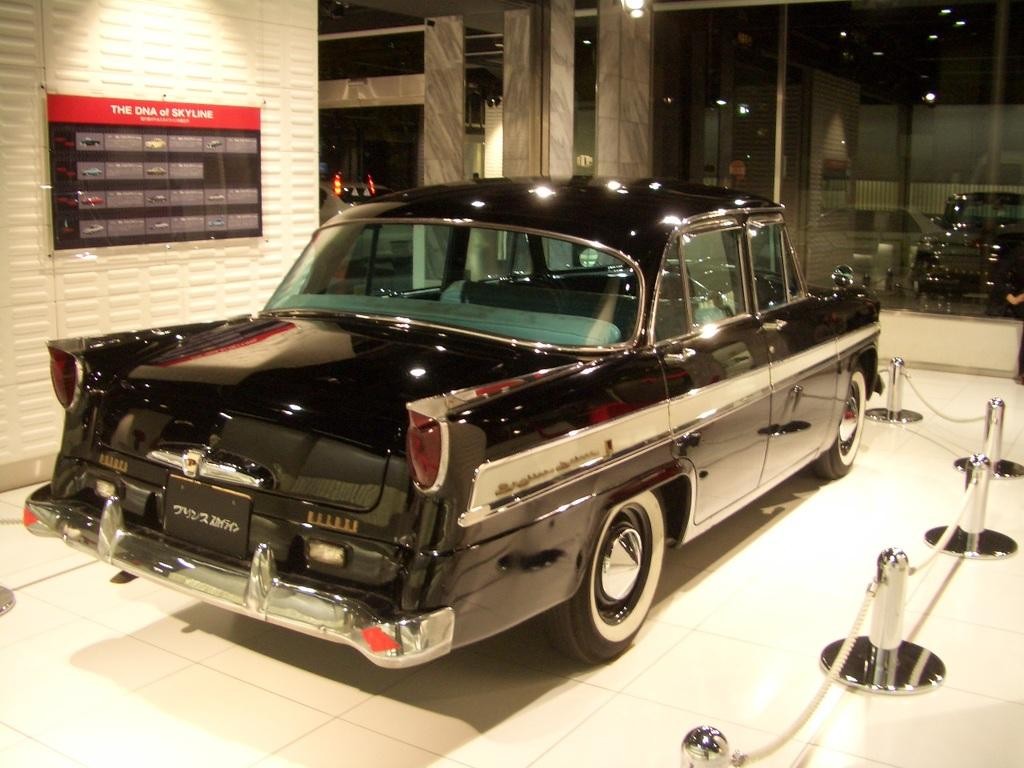What is the main subject of the image? There is a car in the image. Can you describe the car's appearance? The car is stainless steel with a chain. What else can be seen in the image besides the car? There is a glass window, a written text on a board, and a few lights visible in the image. What type of coat is the car wearing in the image? Cars do not wear coats; the car's appearance is described as stainless steel with a chain. Is there any chalk visible in the image? There is no mention of chalk in the provided facts, and it is not visible in the image. 